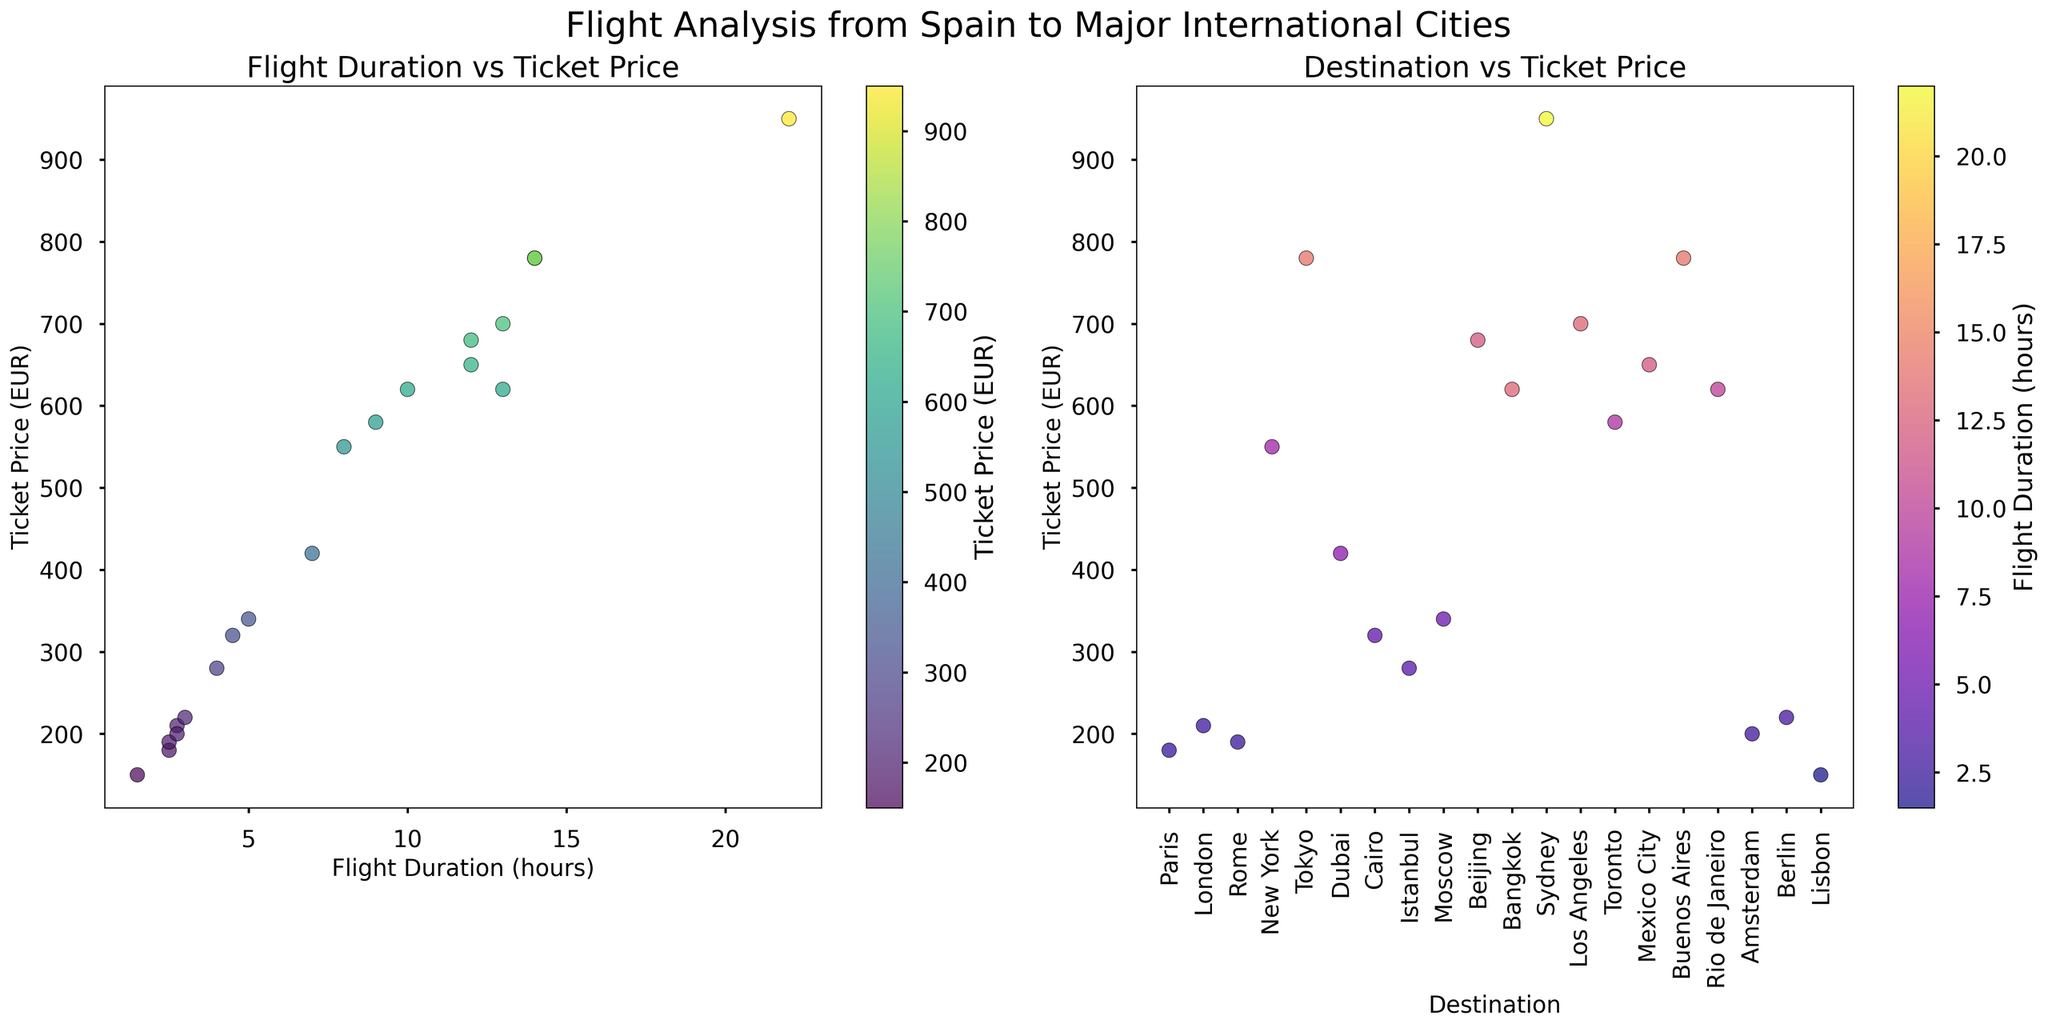What's the title of the figure? The title is located at the top center of the figure and gives an overall idea of what the figure represents.
Answer: Flight Analysis from Spain to Major International Cities What are the labels of the x-axis and y-axis in the first scatter plot? The x-axis and y-axis labels help identify what is being measured on each axis. In the first scatter plot, the x-axis represents "Flight Duration (hours)" and the y-axis represents "Ticket Price (EUR)".
Answer: Flight Duration (hours) and Ticket Price (EUR) How many destinations are shown in the figure? The number of destinations corresponds to the number of unique labels on the x-axis ticks in the second scatter plot.
Answer: 20 Which destination has the longest flight duration and what is the ticket price for that route? By observing the first scatter plot, you can identify the point farthest to the right, which represents the longest flight duration. The associated label in the second scatter plot shows the destination and its ticket price.
Answer: Sydney with a ticket price of 950 EUR Which point represents the shortest flight duration and what observation can be made about its ticket price? The point closest to the left in the first scatter plot indicates the shortest flight duration. Observing the same point in the second scatter plot reveals its ticket price.
Answer: Lisbon with a ticket price of 150 EUR What is the general trend between flight duration and ticket price? By examining the overall distribution of points in the first scatter plot, you can discern if there's an upward or downward trend between flight duration and ticket price.
Answer: As flight duration increases, ticket price generally increases How does the ticket price for flights to Tokyo compare with those to New York? By locating the points for Tokyo and New York on both scatter plots, you can visually compare their ticket prices.
Answer: Tokyo has a higher ticket price than New York What can you say about the concentration of flight durations and ticket prices for European destinations? European destinations tend to cluster together in both scatter plots. In the Flight Duration vs Ticket Price plot, they are concentrated on the left side with lower flight durations and ticket prices.
Answer: European destinations have shorter flight durations and lower ticket prices Which destination has a ticket price of 620 EUR and what is its flight duration? You can identify the point with a ticket price of 620 EUR in the first scatter plot and then match it to the corresponding point in the second scatter plot to find the flight duration and destination.
Answer: Bangkok with a flight duration of 13 hours Is there any destination that has a lower ticket price than 200 EUR and how many such destinations are there? Points below 200 EUR on the vertical axis of both scatter plots show the destinations and their frequency.
Answer: Lisbon with 1 destination 